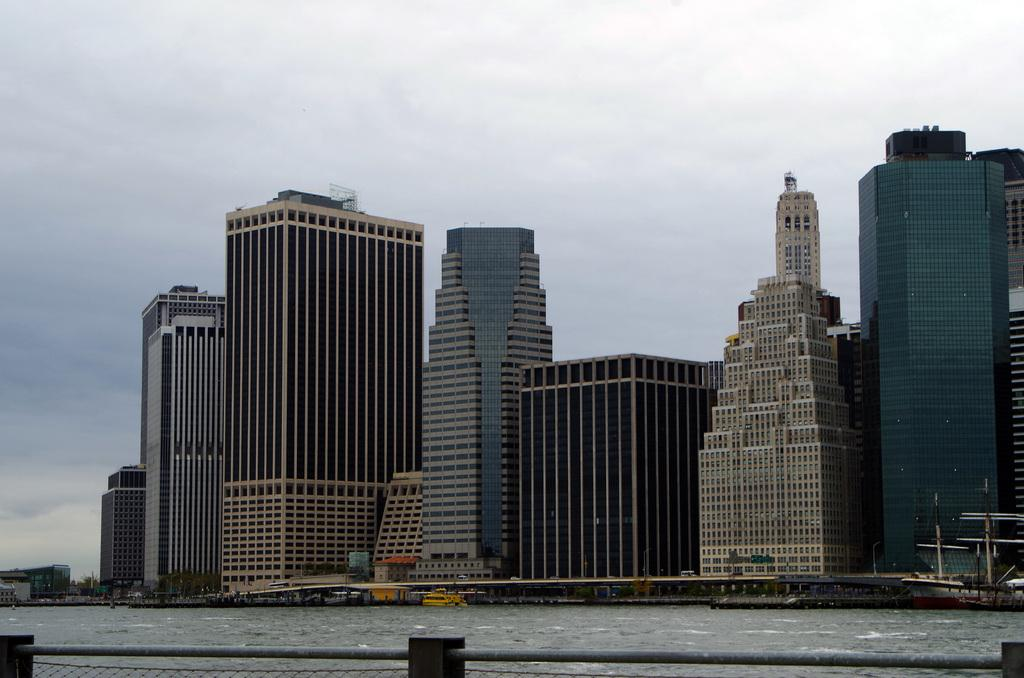What is in the water in the image? There are boats in the water in the image. What can be seen in the background of the image? There are buildings in the background of the image. What type of material is used for the rods visible in the image? The rods visible in the image are made of metal. What type of guitar can be seen hanging on the wall in the image? There is no guitar present in the image; it features boats in the water and buildings in the background. What scientific theory is being discussed in the image? There is no discussion of a scientific theory in the image; it focuses on boats, water, buildings, and metal rods. 